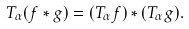Convert formula to latex. <formula><loc_0><loc_0><loc_500><loc_500>T _ { \alpha } ( f * g ) = ( T _ { \alpha } f ) * ( T _ { \alpha } g ) .</formula> 